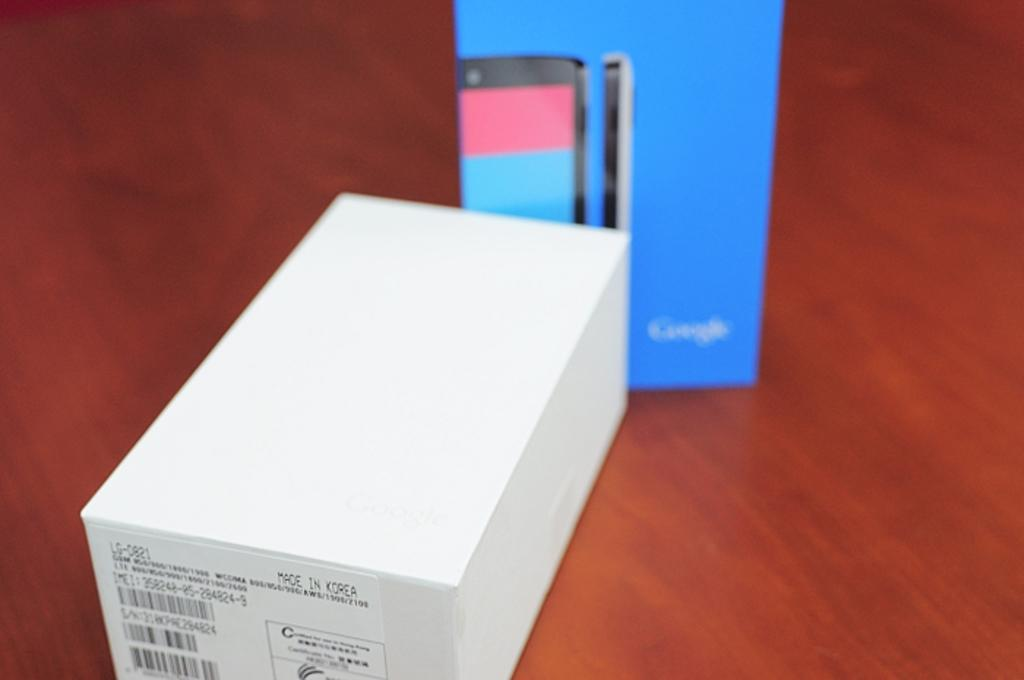What is present in the image in terms of mobile phone packaging? There are two boxes of a mobile phone in the image. Where are the boxes located? The boxes are kept on a surface. What type of science experiment can be seen in the image? There is no science experiment present in the image; it features two boxes of a mobile phone on a surface. Can you identify the queen or wren in the image? There is no queen or wren present in the image. 